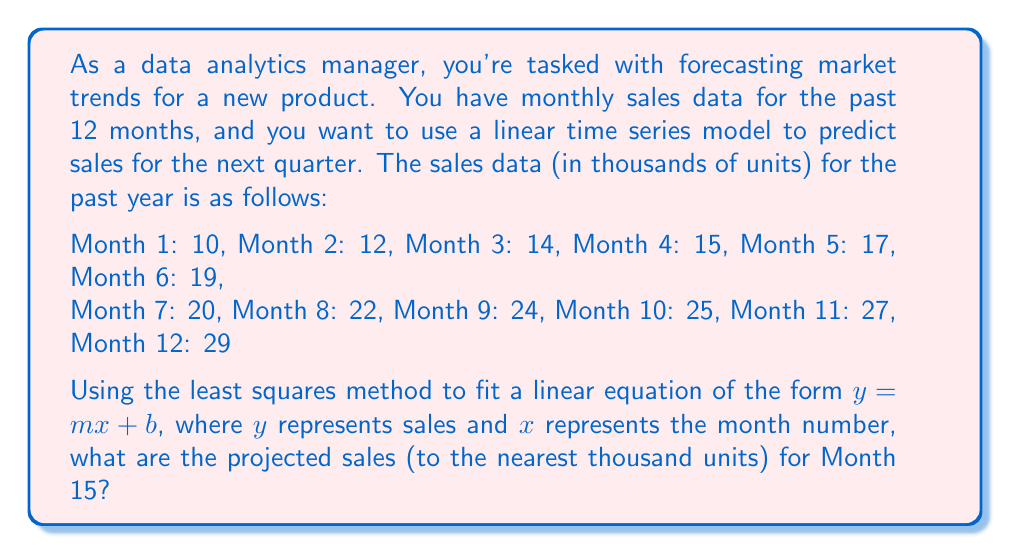Give your solution to this math problem. To solve this problem, we'll follow these steps:

1. Calculate the parameters of the linear equation using the least squares method.
2. Use the resulting equation to forecast sales for Month 15.

Step 1: Calculating the linear equation parameters

For the least squares method, we use the following formulas:

$$m = \frac{n\sum xy - \sum x \sum y}{n\sum x^2 - (\sum x)^2}$$

$$b = \frac{\sum y - m\sum x}{n}$$

Where:
$n$ = number of data points
$x$ = month number
$y$ = sales

Let's calculate the necessary sums:

$n = 12$
$\sum x = 1 + 2 + 3 + ... + 12 = 78$
$\sum y = 10 + 12 + 14 + ... + 29 = 234$
$\sum xy = 1(10) + 2(12) + 3(14) + ... + 12(29) = 3,610$
$\sum x^2 = 1^2 + 2^2 + 3^2 + ... + 12^2 = 650$

Now, let's substitute these values into our formulas:

$$m = \frac{12(3,610) - 78(234)}{12(650) - 78^2} = \frac{43,320 - 18,252}{7,800 - 6,084} = \frac{25,068}{1,716} \approx 1.6007$$

$$b = \frac{234 - 1.6007(78)}{12} \approx 8.4945$$

Our linear equation is approximately:

$$y = 1.6007x + 8.4945$$

Step 2: Forecasting sales for Month 15

To forecast sales for Month 15, we simply substitute $x = 15$ into our equation:

$$y = 1.6007(15) + 8.4945 \approx 32.5050$$

Rounding to the nearest thousand units, we get 33,000 units.
Answer: 33,000 units 